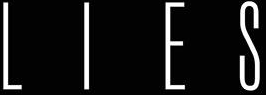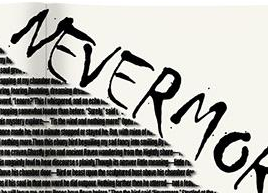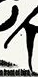What text is displayed in these images sequentially, separated by a semicolon? LIES; NEVERMO; # 